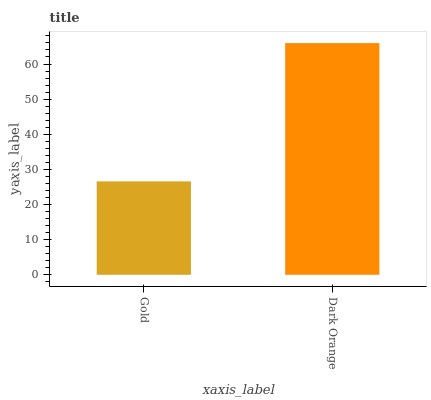Is Gold the minimum?
Answer yes or no. Yes. Is Dark Orange the maximum?
Answer yes or no. Yes. Is Dark Orange the minimum?
Answer yes or no. No. Is Dark Orange greater than Gold?
Answer yes or no. Yes. Is Gold less than Dark Orange?
Answer yes or no. Yes. Is Gold greater than Dark Orange?
Answer yes or no. No. Is Dark Orange less than Gold?
Answer yes or no. No. Is Dark Orange the high median?
Answer yes or no. Yes. Is Gold the low median?
Answer yes or no. Yes. Is Gold the high median?
Answer yes or no. No. Is Dark Orange the low median?
Answer yes or no. No. 